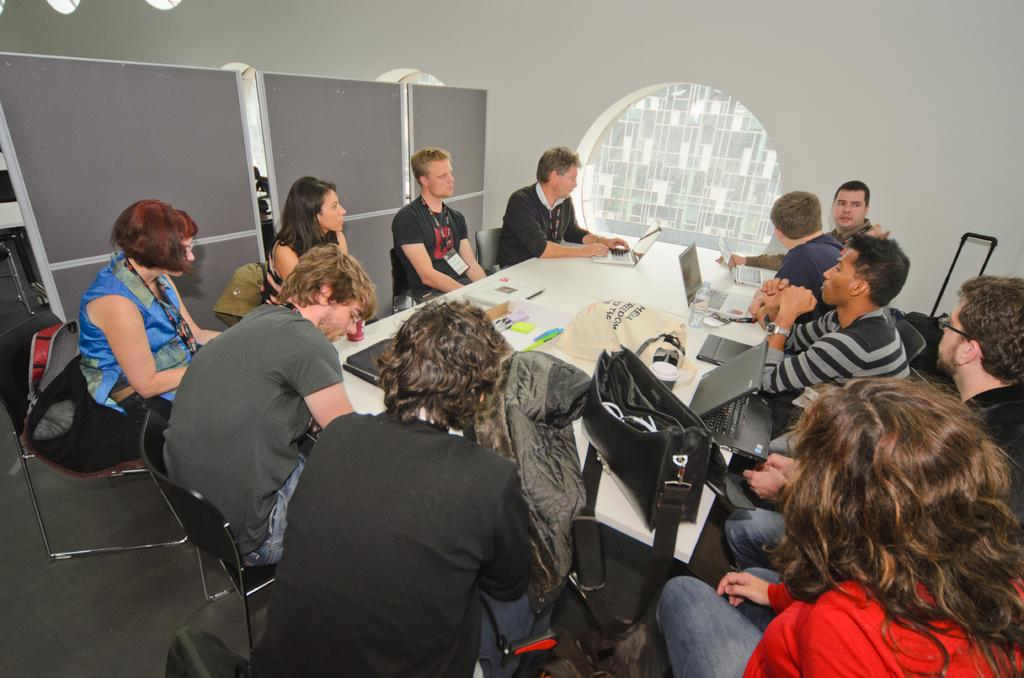How many people are in the image? There is a group of people in the image. What are the people doing in the image? The people are sitting on chairs. What is in front of the people? There is a table in front of the people. What items can be seen on the table? Laptops and bags are present on the table. Where is the shelf located in the image? There is no shelf present in the image. What authority figure can be seen in the image? There is no authority figure mentioned in the provided facts, and the image does not show any specific person in a position of authority. 